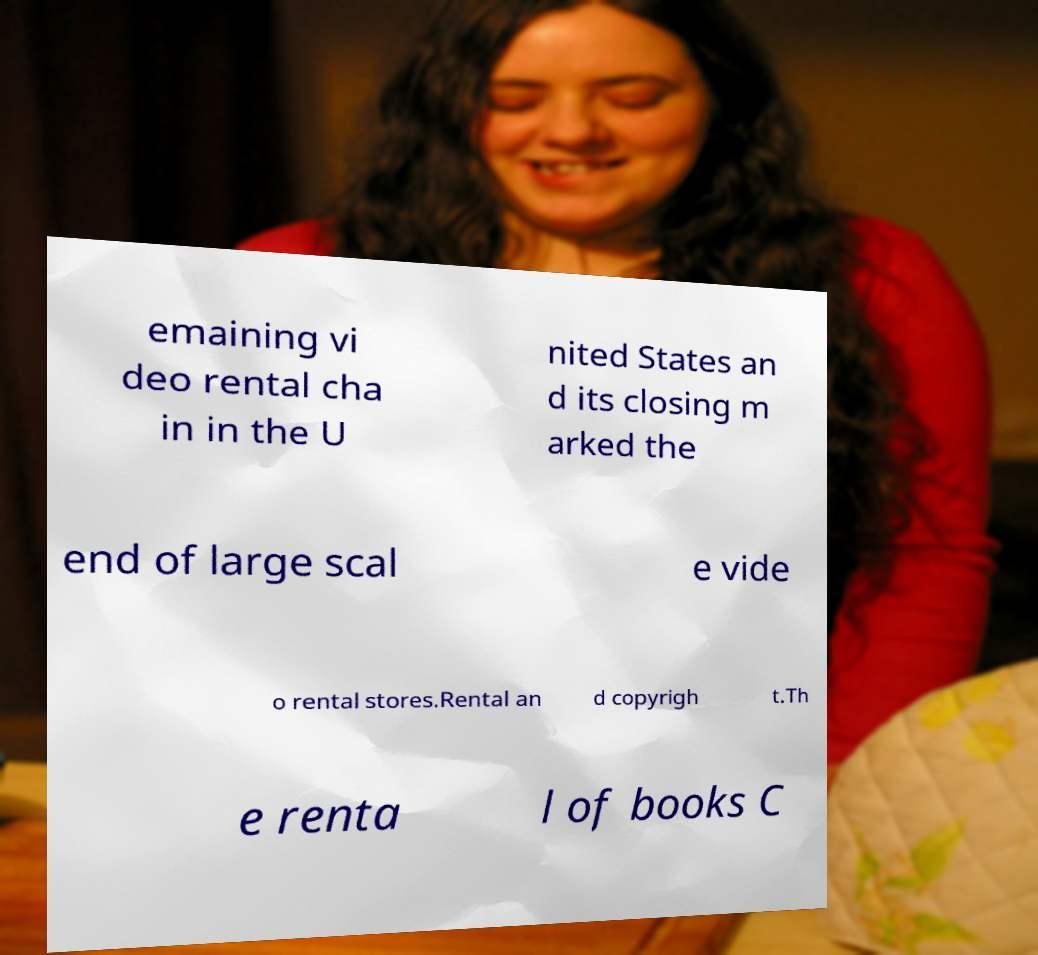Please identify and transcribe the text found in this image. emaining vi deo rental cha in in the U nited States an d its closing m arked the end of large scal e vide o rental stores.Rental an d copyrigh t.Th e renta l of books C 